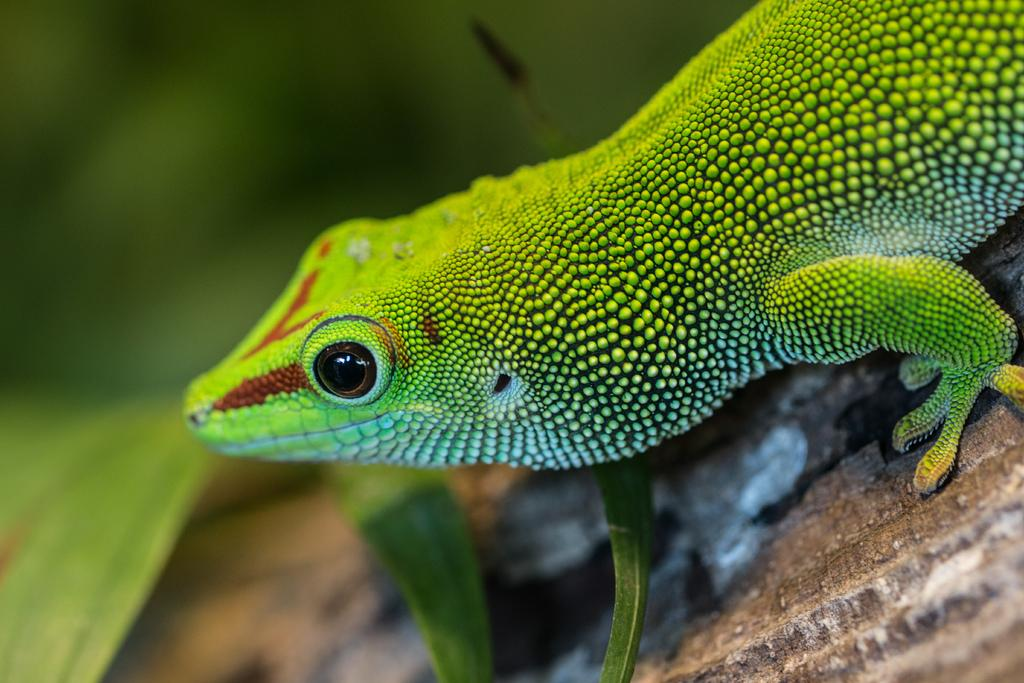What type of animal is in the image? There is a green lizard in the image. What is the lizard resting on? The lizard is on wood. What other natural elements are present in the image? There are leaves beside the lizard. What type of account does the lizard have with the bank in the image? There is no indication of a bank or any accounts in the image; it features a green lizard on wood with leaves beside it. 